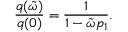Convert formula to latex. <formula><loc_0><loc_0><loc_500><loc_500>\frac { q ( \tilde { \omega } ) } { q ( 0 ) } = \frac { 1 } { 1 - \tilde { \omega } p _ { 1 } } .</formula> 